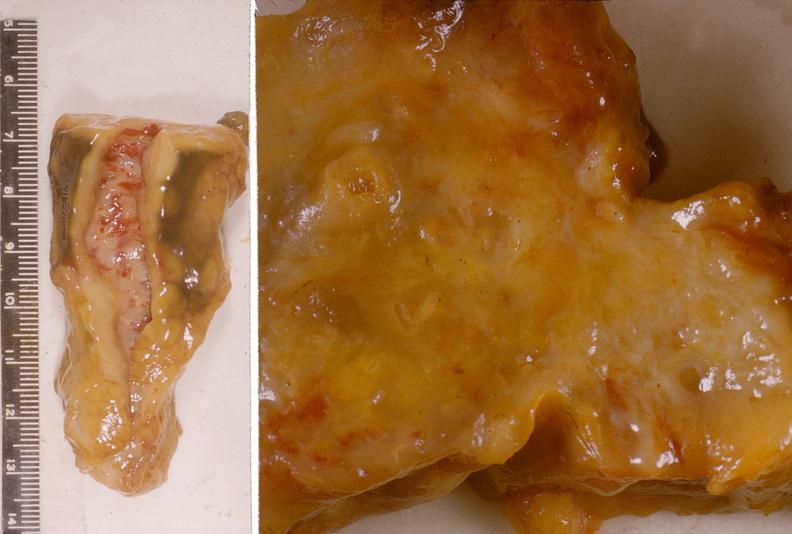what does this image show?
Answer the question using a single word or phrase. Adenocarcinoma 